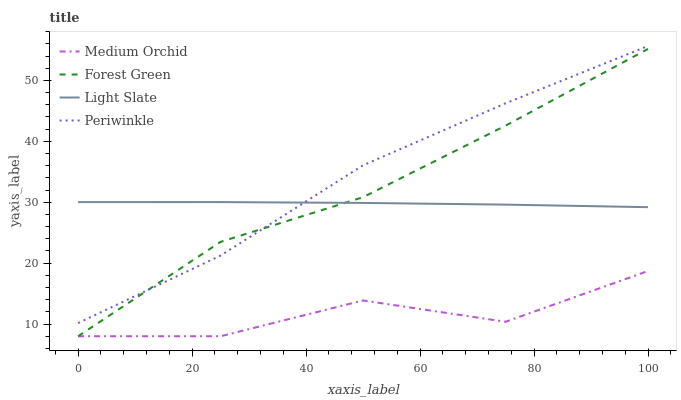Does Medium Orchid have the minimum area under the curve?
Answer yes or no. Yes. Does Periwinkle have the maximum area under the curve?
Answer yes or no. Yes. Does Forest Green have the minimum area under the curve?
Answer yes or no. No. Does Forest Green have the maximum area under the curve?
Answer yes or no. No. Is Light Slate the smoothest?
Answer yes or no. Yes. Is Medium Orchid the roughest?
Answer yes or no. Yes. Is Forest Green the smoothest?
Answer yes or no. No. Is Forest Green the roughest?
Answer yes or no. No. Does Periwinkle have the lowest value?
Answer yes or no. No. Does Forest Green have the highest value?
Answer yes or no. No. Is Medium Orchid less than Periwinkle?
Answer yes or no. Yes. Is Periwinkle greater than Medium Orchid?
Answer yes or no. Yes. Does Medium Orchid intersect Periwinkle?
Answer yes or no. No. 